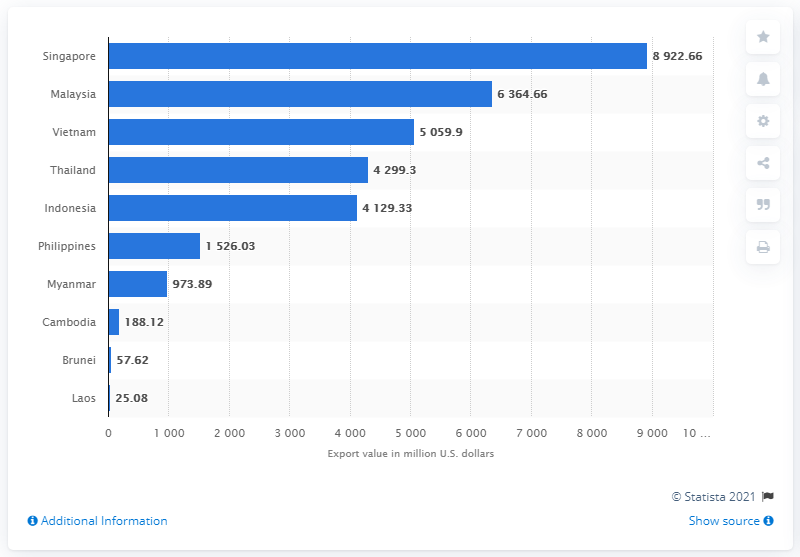Point out several critical features in this image. In fiscal year 2020, Malaysia was the second country in terms of the value of Indian goods exported to Singapore. 